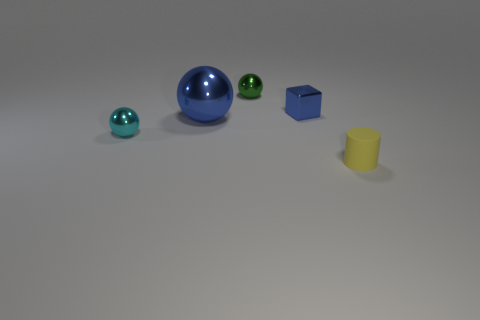There is a ball that is the same color as the tiny shiny block; what size is it?
Your answer should be compact. Large. The small thing that is the same color as the big shiny object is what shape?
Keep it short and to the point. Cube. There is a tiny object that is in front of the cyan object; what is its shape?
Offer a very short reply. Cylinder. What number of brown objects are either big balls or metal things?
Your answer should be compact. 0. Do the small green ball and the large ball have the same material?
Give a very brief answer. Yes. There is a big shiny ball; how many small cyan shiny spheres are on the left side of it?
Offer a very short reply. 1. What is the material of the small thing that is both on the left side of the yellow rubber thing and in front of the small metal cube?
Offer a very short reply. Metal. What number of cubes are blue metallic things or green metallic objects?
Ensure brevity in your answer.  1. What is the material of the small cyan thing that is the same shape as the large blue object?
Provide a short and direct response. Metal. What size is the blue object that is the same material as the big blue ball?
Make the answer very short. Small. 